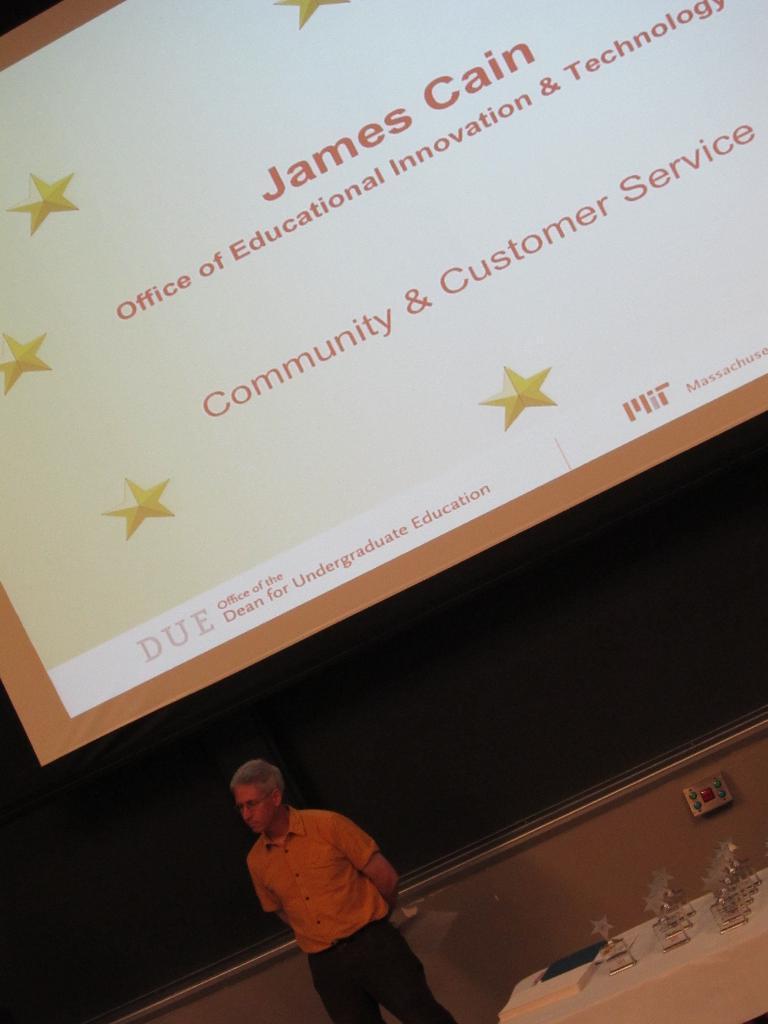Please provide a concise description of this image. In this image we can see a person standing on the floor and a table is placed beside him. On the table there are mementos and a file. In the background we can see the display screen. 